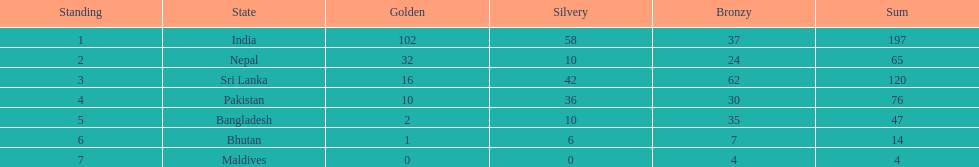What is the difference in total number of medals between india and nepal? 132. 